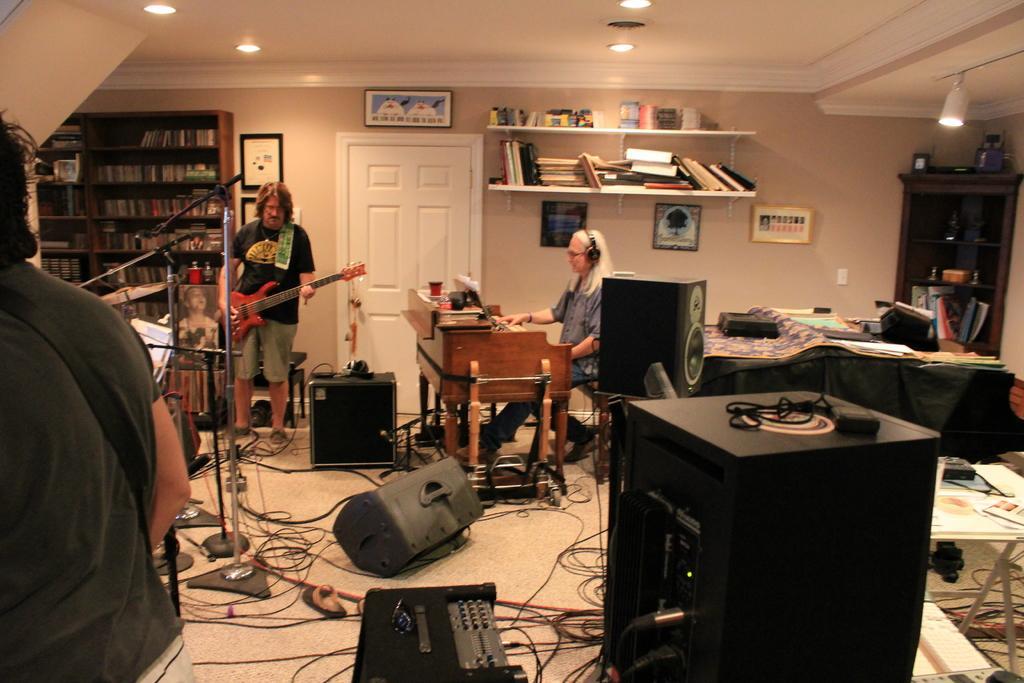Could you give a brief overview of what you see in this image? In this picture I can see there is a person at right playing the piano, the person at the left is holding the guitar and there are few speakers, cables and microphones. There is a bookshelf in the backdrop with books. 